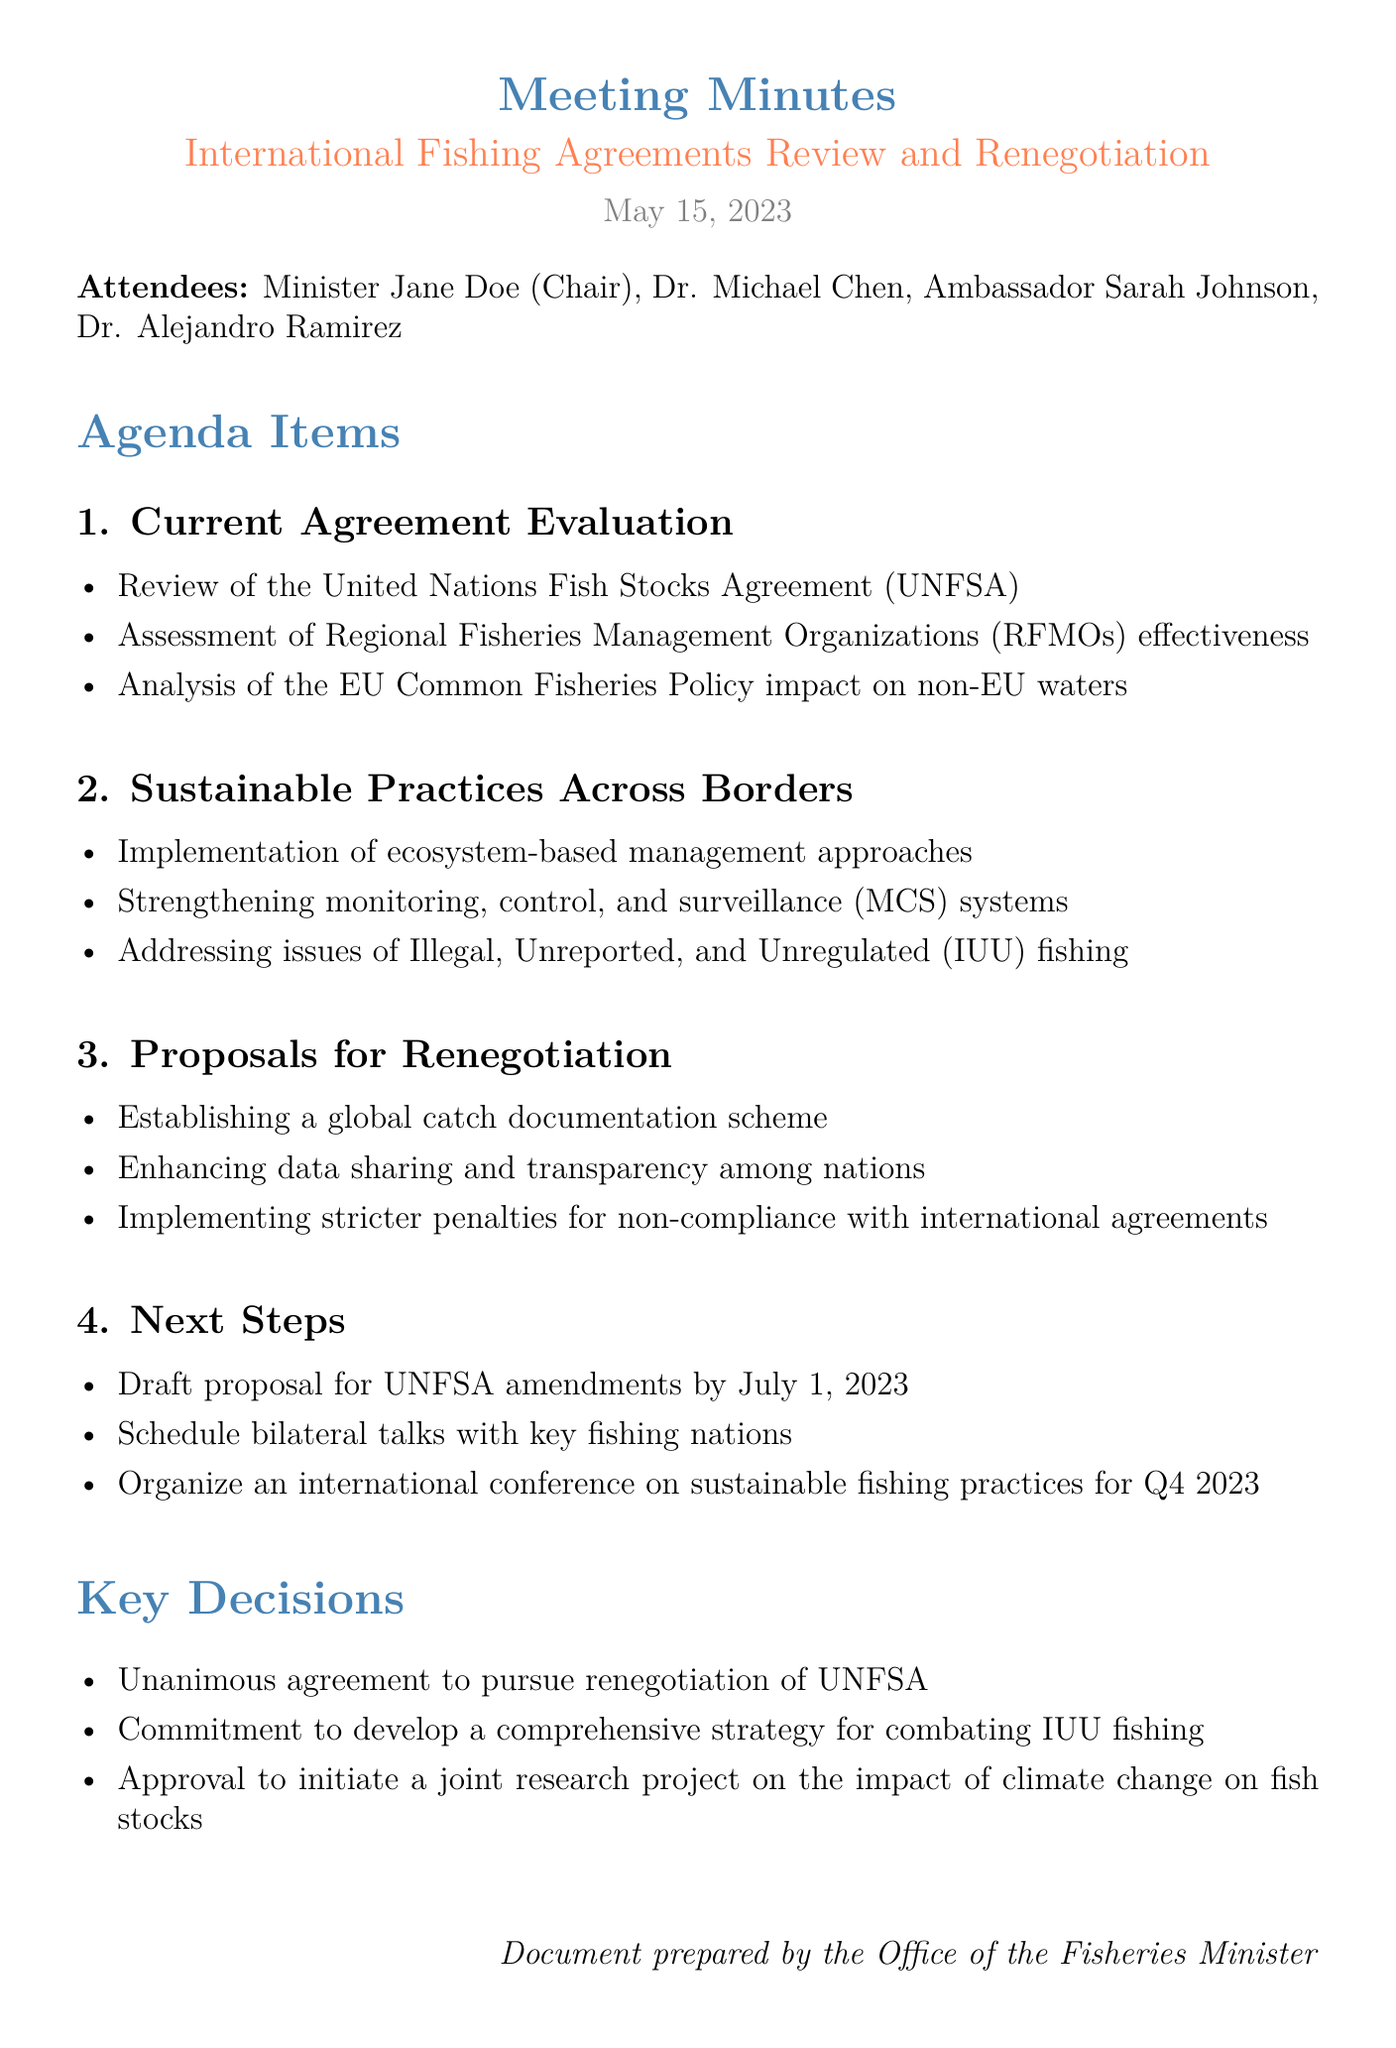What is the date of the meeting? The date of the meeting is mentioned in the document’s header.
Answer: May 15, 2023 Who chaired the meeting? The chairperson of the meeting is listed in the attendees section.
Answer: Minister Jane Doe What is one of the key points in the "Sustainable Practices Across Borders" agenda item? The document provides key points under each agenda item, listing practices for sustainability.
Answer: Implementation of ecosystem-based management approaches How many attendees were there at the meeting? The number of attendees can be counted from the attendees section.
Answer: 4 What is one proposal for renegotiation mentioned? The proposals for renegotiation are listed under the respective agenda topic.
Answer: Establishing a global catch documentation scheme Which organization’s effectiveness was assessed in the current agreement evaluation? The document specifies organizations being evaluated in the agenda items section.
Answer: Regional Fisheries Management Organizations What is the deadline to draft the proposal for UNFSA amendments? The deadline is explicitly mentioned in the "Next Steps" section of the document.
Answer: July 1, 2023 What was the unanimous decision made at the meeting? The key decisions made at the meeting are concise and listed in a bullet format.
Answer: To pursue renegotiation of UNFSA What future event is scheduled for Q4 2023? The document outlines planned actions in the "Next Steps" section regarding future events.
Answer: An international conference on sustainable fishing practices 